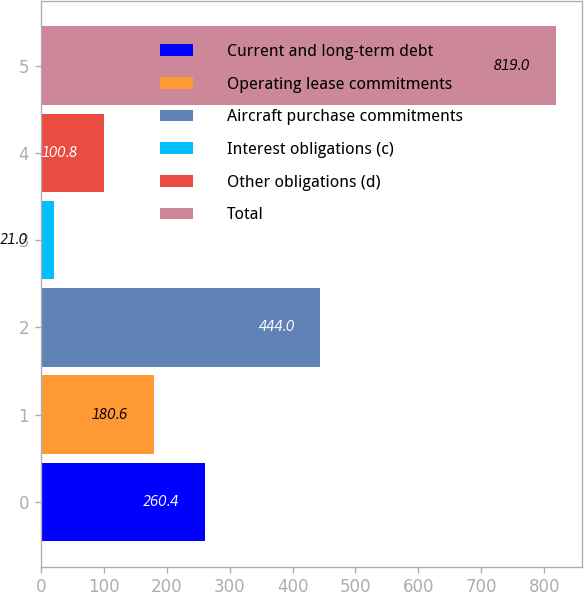<chart> <loc_0><loc_0><loc_500><loc_500><bar_chart><fcel>Current and long-term debt<fcel>Operating lease commitments<fcel>Aircraft purchase commitments<fcel>Interest obligations (c)<fcel>Other obligations (d)<fcel>Total<nl><fcel>260.4<fcel>180.6<fcel>444<fcel>21<fcel>100.8<fcel>819<nl></chart> 